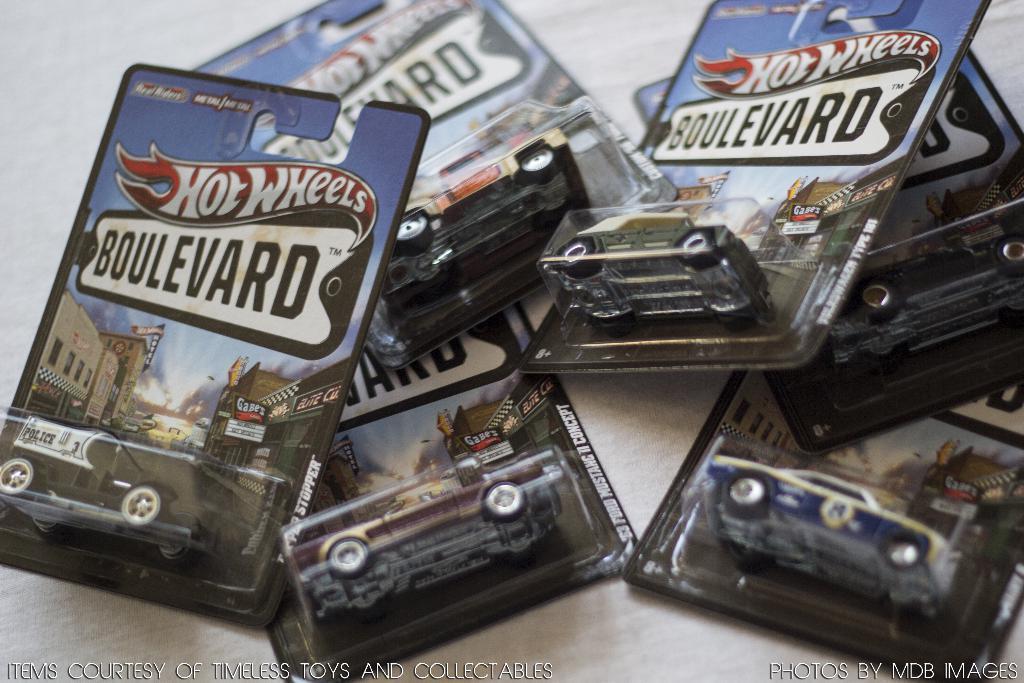In one or two sentences, can you explain what this image depicts? In this image I can see few packets in which I can see few toy cars which are black, brown, red, green, white and blue in color. I can see these are on the white colored surface. 